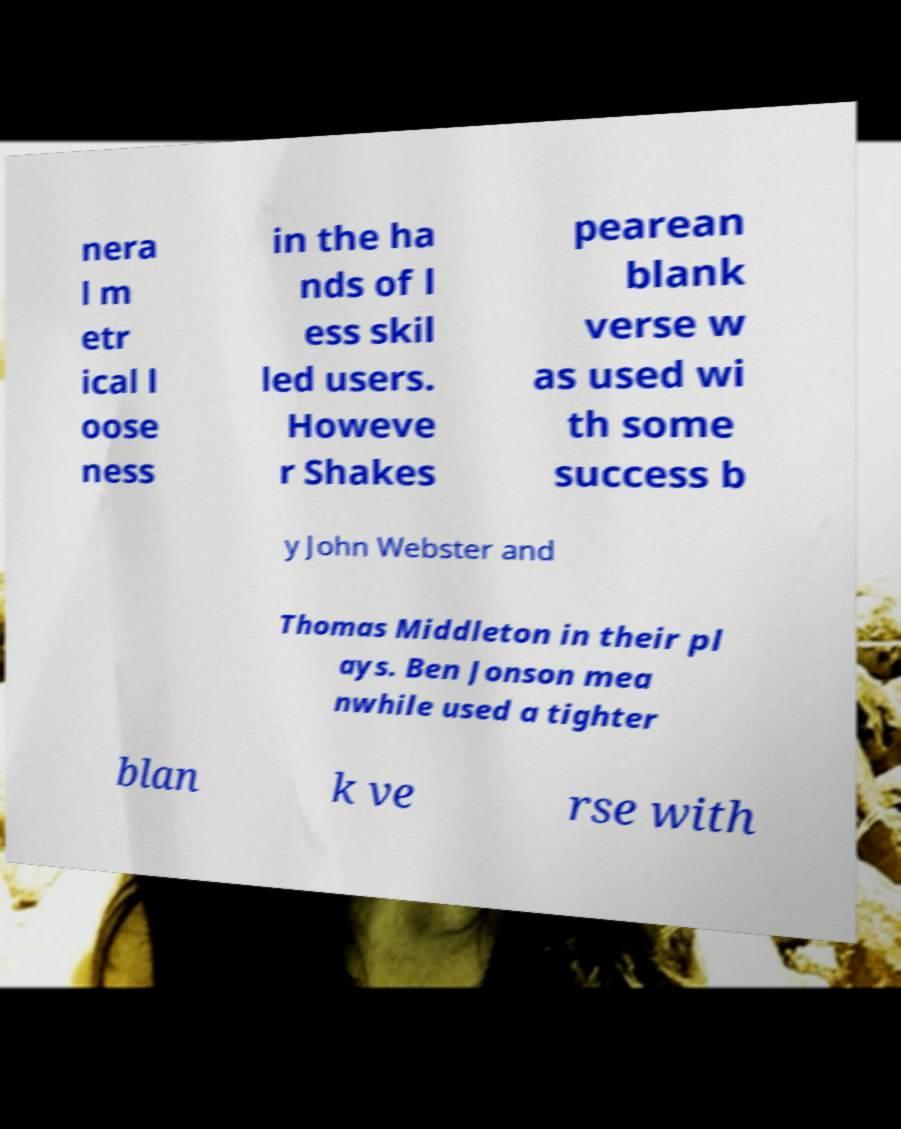Please identify and transcribe the text found in this image. nera l m etr ical l oose ness in the ha nds of l ess skil led users. Howeve r Shakes pearean blank verse w as used wi th some success b y John Webster and Thomas Middleton in their pl ays. Ben Jonson mea nwhile used a tighter blan k ve rse with 